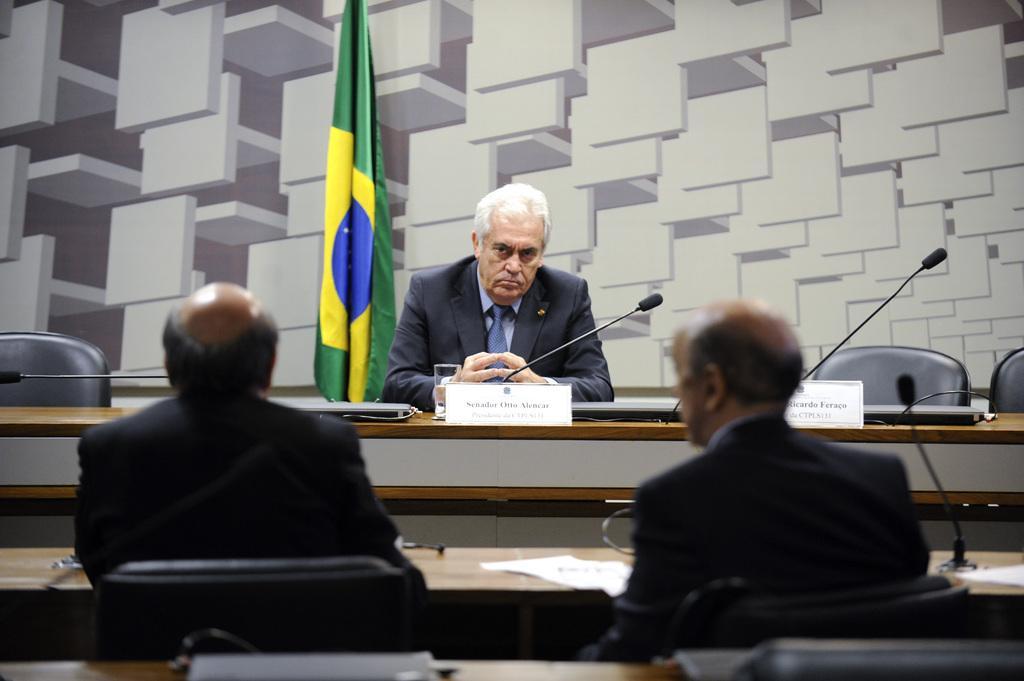Describe this image in one or two sentences. As we can see in the image there are three persons wearing black color jackets. There are chairs, tables, papers, mics and a flag. 